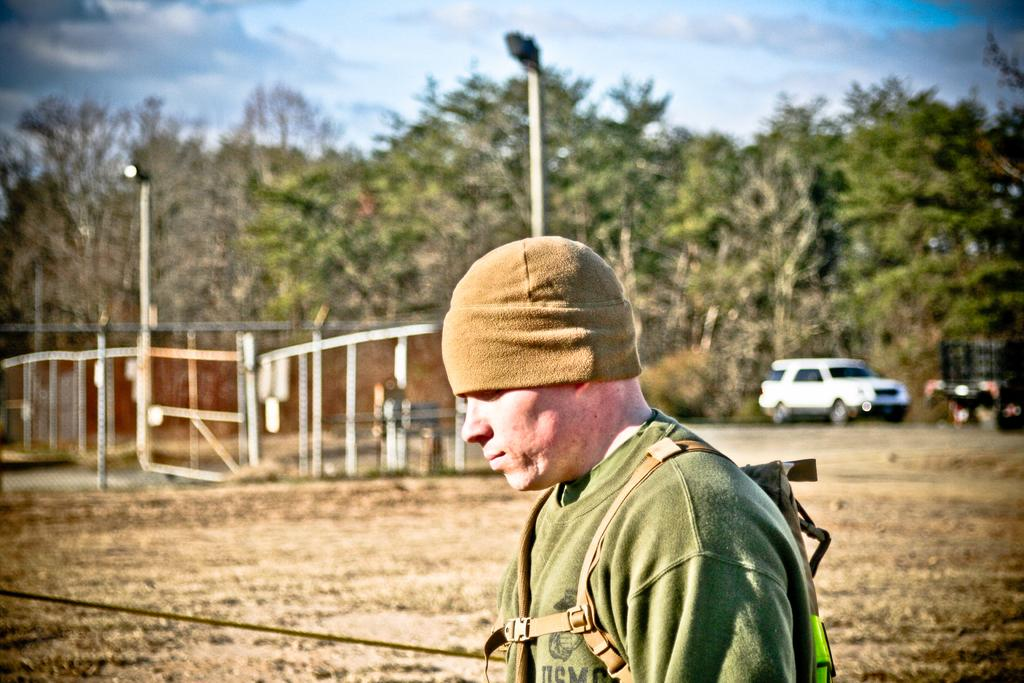Where was the image taken? The image is clicked outside. What can be seen in the middle of the image? There are trees in the middle of the image. What is located on the right side of the image? There is a car on the right side of the image. Who is present in the middle of the image? There is a man in the middle of the image. What is visible at the top of the image? The sky is visible at the top of the image. What type of company is the man working for in the image? There is no indication in the image that the man is working for a company. What is the man gripping in the image? There is no object being gripped by the man in the image. 